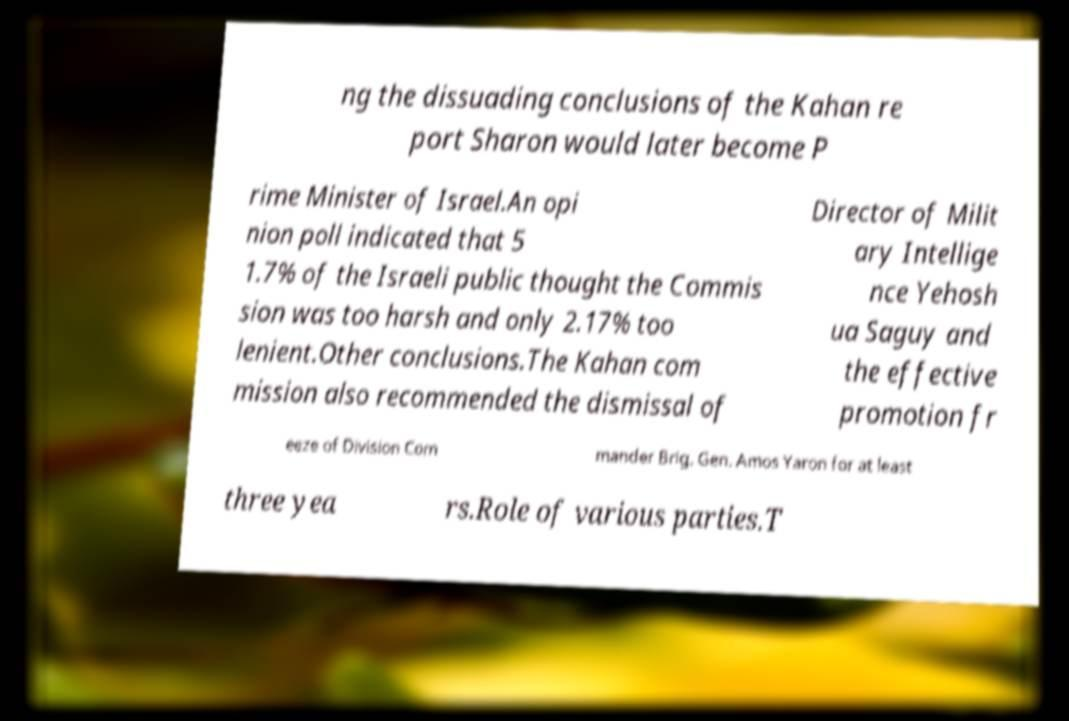Could you extract and type out the text from this image? ng the dissuading conclusions of the Kahan re port Sharon would later become P rime Minister of Israel.An opi nion poll indicated that 5 1.7% of the Israeli public thought the Commis sion was too harsh and only 2.17% too lenient.Other conclusions.The Kahan com mission also recommended the dismissal of Director of Milit ary Intellige nce Yehosh ua Saguy and the effective promotion fr eeze of Division Com mander Brig. Gen. Amos Yaron for at least three yea rs.Role of various parties.T 